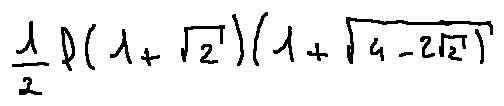<formula> <loc_0><loc_0><loc_500><loc_500>\frac { 1 } { 2 } l ( 1 + \sqrt { 2 } ) ( 1 + \sqrt { 4 - 2 \sqrt { 2 } } )</formula> 